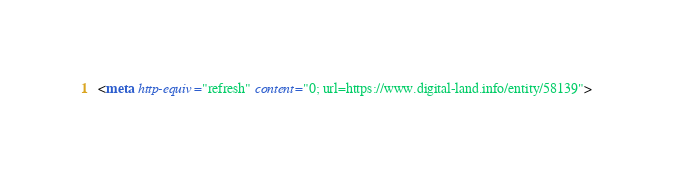Convert code to text. <code><loc_0><loc_0><loc_500><loc_500><_HTML_><meta http-equiv="refresh" content="0; url=https://www.digital-land.info/entity/58139"></code> 